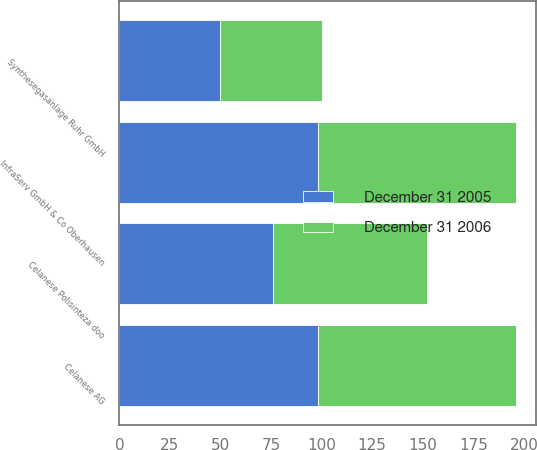Convert chart to OTSL. <chart><loc_0><loc_0><loc_500><loc_500><stacked_bar_chart><ecel><fcel>Celanese AG<fcel>InfraServ GmbH & Co Oberhausen<fcel>Celanese Polisinteza doo<fcel>Synthesegasanlage Ruhr GmbH<nl><fcel>December 31 2005<fcel>98<fcel>98<fcel>76<fcel>50<nl><fcel>December 31 2006<fcel>98<fcel>98<fcel>76<fcel>50<nl></chart> 